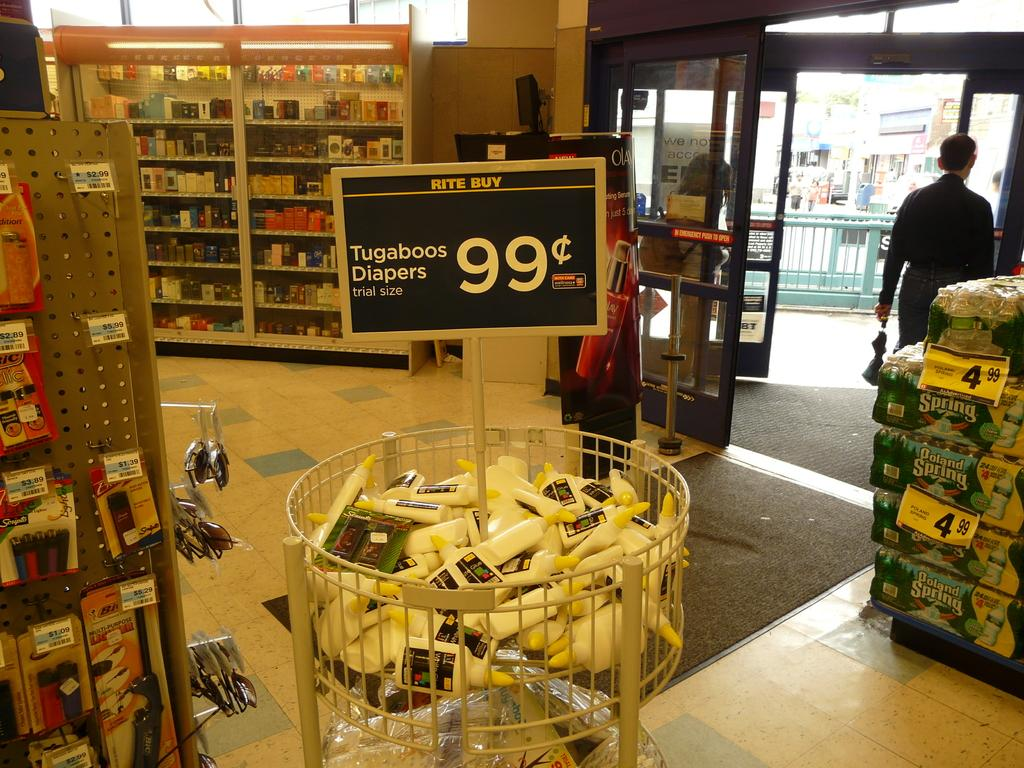Provide a one-sentence caption for the provided image. Trial sizes of Tugaboos Diapers for sale for only 99 cents. 